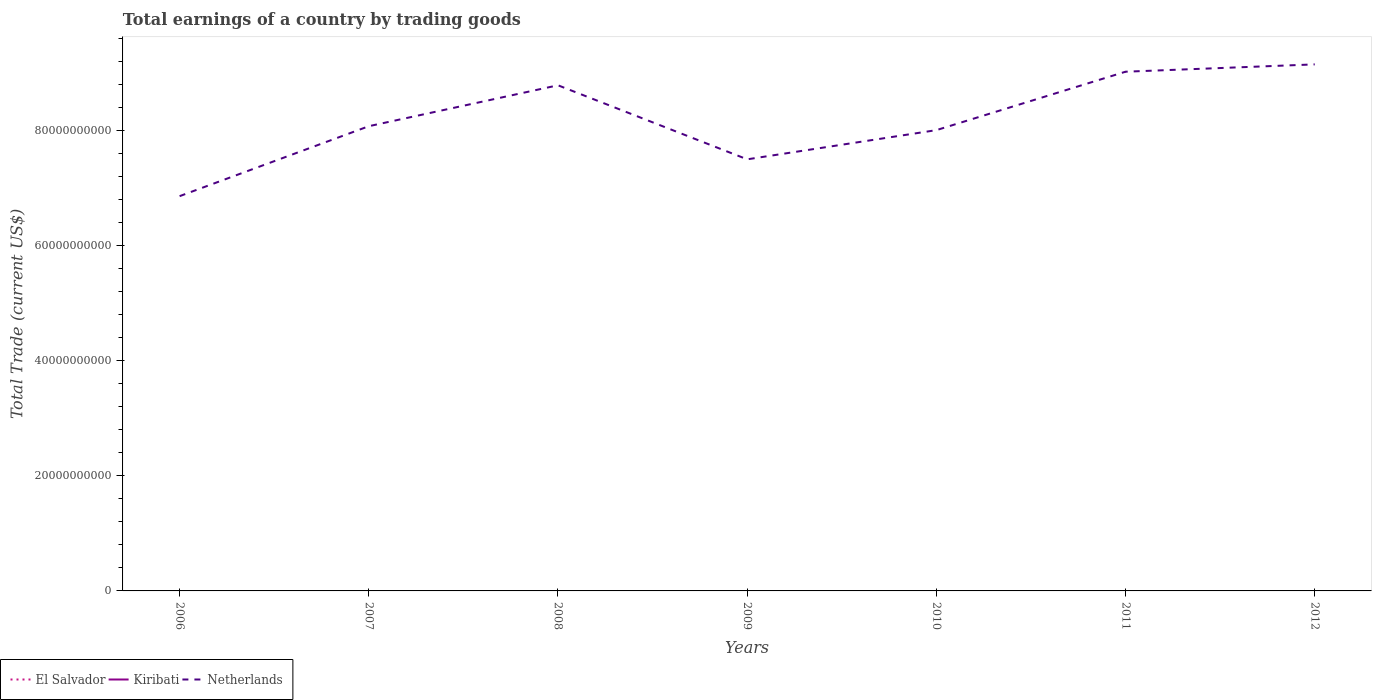How many different coloured lines are there?
Make the answer very short. 1. Does the line corresponding to Netherlands intersect with the line corresponding to El Salvador?
Offer a very short reply. No. Is the number of lines equal to the number of legend labels?
Your answer should be very brief. No. Across all years, what is the maximum total earnings in El Salvador?
Ensure brevity in your answer.  0. What is the total total earnings in Netherlands in the graph?
Ensure brevity in your answer.  -9.47e+09. What is the difference between the highest and the second highest total earnings in Netherlands?
Make the answer very short. 2.29e+1. Is the total earnings in Netherlands strictly greater than the total earnings in Kiribati over the years?
Offer a very short reply. No. How many lines are there?
Make the answer very short. 1. How many years are there in the graph?
Offer a terse response. 7. What is the difference between two consecutive major ticks on the Y-axis?
Your answer should be compact. 2.00e+1. Are the values on the major ticks of Y-axis written in scientific E-notation?
Ensure brevity in your answer.  No. Does the graph contain grids?
Your response must be concise. No. Where does the legend appear in the graph?
Provide a short and direct response. Bottom left. How many legend labels are there?
Your response must be concise. 3. What is the title of the graph?
Ensure brevity in your answer.  Total earnings of a country by trading goods. Does "Peru" appear as one of the legend labels in the graph?
Ensure brevity in your answer.  No. What is the label or title of the Y-axis?
Offer a terse response. Total Trade (current US$). What is the Total Trade (current US$) of El Salvador in 2006?
Make the answer very short. 0. What is the Total Trade (current US$) of Kiribati in 2006?
Your answer should be compact. 0. What is the Total Trade (current US$) of Netherlands in 2006?
Your response must be concise. 6.86e+1. What is the Total Trade (current US$) of El Salvador in 2007?
Ensure brevity in your answer.  0. What is the Total Trade (current US$) in Netherlands in 2007?
Give a very brief answer. 8.07e+1. What is the Total Trade (current US$) in Kiribati in 2008?
Offer a very short reply. 0. What is the Total Trade (current US$) in Netherlands in 2008?
Provide a succinct answer. 8.78e+1. What is the Total Trade (current US$) in El Salvador in 2009?
Your response must be concise. 0. What is the Total Trade (current US$) in Netherlands in 2009?
Your answer should be very brief. 7.50e+1. What is the Total Trade (current US$) of El Salvador in 2010?
Keep it short and to the point. 0. What is the Total Trade (current US$) in Netherlands in 2010?
Make the answer very short. 8.00e+1. What is the Total Trade (current US$) of Netherlands in 2011?
Keep it short and to the point. 9.02e+1. What is the Total Trade (current US$) in El Salvador in 2012?
Offer a terse response. 0. What is the Total Trade (current US$) of Kiribati in 2012?
Offer a very short reply. 0. What is the Total Trade (current US$) in Netherlands in 2012?
Offer a very short reply. 9.15e+1. Across all years, what is the maximum Total Trade (current US$) in Netherlands?
Keep it short and to the point. 9.15e+1. Across all years, what is the minimum Total Trade (current US$) of Netherlands?
Make the answer very short. 6.86e+1. What is the total Total Trade (current US$) in El Salvador in the graph?
Your answer should be very brief. 0. What is the total Total Trade (current US$) in Netherlands in the graph?
Provide a succinct answer. 5.74e+11. What is the difference between the Total Trade (current US$) in Netherlands in 2006 and that in 2007?
Provide a short and direct response. -1.22e+1. What is the difference between the Total Trade (current US$) in Netherlands in 2006 and that in 2008?
Your answer should be very brief. -1.93e+1. What is the difference between the Total Trade (current US$) of Netherlands in 2006 and that in 2009?
Your answer should be very brief. -6.40e+09. What is the difference between the Total Trade (current US$) in Netherlands in 2006 and that in 2010?
Your answer should be compact. -1.15e+1. What is the difference between the Total Trade (current US$) in Netherlands in 2006 and that in 2011?
Offer a very short reply. -2.16e+1. What is the difference between the Total Trade (current US$) of Netherlands in 2006 and that in 2012?
Provide a succinct answer. -2.29e+1. What is the difference between the Total Trade (current US$) in Netherlands in 2007 and that in 2008?
Provide a succinct answer. -7.11e+09. What is the difference between the Total Trade (current US$) of Netherlands in 2007 and that in 2009?
Give a very brief answer. 5.76e+09. What is the difference between the Total Trade (current US$) in Netherlands in 2007 and that in 2010?
Give a very brief answer. 6.83e+08. What is the difference between the Total Trade (current US$) of Netherlands in 2007 and that in 2011?
Your answer should be very brief. -9.47e+09. What is the difference between the Total Trade (current US$) in Netherlands in 2007 and that in 2012?
Your answer should be compact. -1.07e+1. What is the difference between the Total Trade (current US$) in Netherlands in 2008 and that in 2009?
Offer a terse response. 1.29e+1. What is the difference between the Total Trade (current US$) in Netherlands in 2008 and that in 2010?
Offer a terse response. 7.79e+09. What is the difference between the Total Trade (current US$) in Netherlands in 2008 and that in 2011?
Your response must be concise. -2.36e+09. What is the difference between the Total Trade (current US$) in Netherlands in 2008 and that in 2012?
Offer a terse response. -3.63e+09. What is the difference between the Total Trade (current US$) in Netherlands in 2009 and that in 2010?
Your answer should be very brief. -5.07e+09. What is the difference between the Total Trade (current US$) of Netherlands in 2009 and that in 2011?
Give a very brief answer. -1.52e+1. What is the difference between the Total Trade (current US$) in Netherlands in 2009 and that in 2012?
Your answer should be very brief. -1.65e+1. What is the difference between the Total Trade (current US$) of Netherlands in 2010 and that in 2011?
Your response must be concise. -1.01e+1. What is the difference between the Total Trade (current US$) of Netherlands in 2010 and that in 2012?
Make the answer very short. -1.14e+1. What is the difference between the Total Trade (current US$) in Netherlands in 2011 and that in 2012?
Your answer should be very brief. -1.27e+09. What is the average Total Trade (current US$) in Netherlands per year?
Ensure brevity in your answer.  8.20e+1. What is the ratio of the Total Trade (current US$) of Netherlands in 2006 to that in 2007?
Make the answer very short. 0.85. What is the ratio of the Total Trade (current US$) in Netherlands in 2006 to that in 2008?
Offer a terse response. 0.78. What is the ratio of the Total Trade (current US$) of Netherlands in 2006 to that in 2009?
Your response must be concise. 0.91. What is the ratio of the Total Trade (current US$) in Netherlands in 2006 to that in 2010?
Keep it short and to the point. 0.86. What is the ratio of the Total Trade (current US$) in Netherlands in 2006 to that in 2011?
Your answer should be very brief. 0.76. What is the ratio of the Total Trade (current US$) in Netherlands in 2006 to that in 2012?
Offer a very short reply. 0.75. What is the ratio of the Total Trade (current US$) in Netherlands in 2007 to that in 2008?
Ensure brevity in your answer.  0.92. What is the ratio of the Total Trade (current US$) of Netherlands in 2007 to that in 2009?
Your answer should be compact. 1.08. What is the ratio of the Total Trade (current US$) in Netherlands in 2007 to that in 2010?
Keep it short and to the point. 1.01. What is the ratio of the Total Trade (current US$) of Netherlands in 2007 to that in 2011?
Provide a succinct answer. 0.9. What is the ratio of the Total Trade (current US$) of Netherlands in 2007 to that in 2012?
Make the answer very short. 0.88. What is the ratio of the Total Trade (current US$) of Netherlands in 2008 to that in 2009?
Your response must be concise. 1.17. What is the ratio of the Total Trade (current US$) in Netherlands in 2008 to that in 2010?
Provide a succinct answer. 1.1. What is the ratio of the Total Trade (current US$) of Netherlands in 2008 to that in 2011?
Provide a succinct answer. 0.97. What is the ratio of the Total Trade (current US$) of Netherlands in 2008 to that in 2012?
Make the answer very short. 0.96. What is the ratio of the Total Trade (current US$) in Netherlands in 2009 to that in 2010?
Your answer should be very brief. 0.94. What is the ratio of the Total Trade (current US$) of Netherlands in 2009 to that in 2011?
Your response must be concise. 0.83. What is the ratio of the Total Trade (current US$) in Netherlands in 2009 to that in 2012?
Keep it short and to the point. 0.82. What is the ratio of the Total Trade (current US$) in Netherlands in 2010 to that in 2011?
Provide a succinct answer. 0.89. What is the ratio of the Total Trade (current US$) in Netherlands in 2010 to that in 2012?
Ensure brevity in your answer.  0.88. What is the ratio of the Total Trade (current US$) of Netherlands in 2011 to that in 2012?
Provide a succinct answer. 0.99. What is the difference between the highest and the second highest Total Trade (current US$) of Netherlands?
Keep it short and to the point. 1.27e+09. What is the difference between the highest and the lowest Total Trade (current US$) in Netherlands?
Make the answer very short. 2.29e+1. 